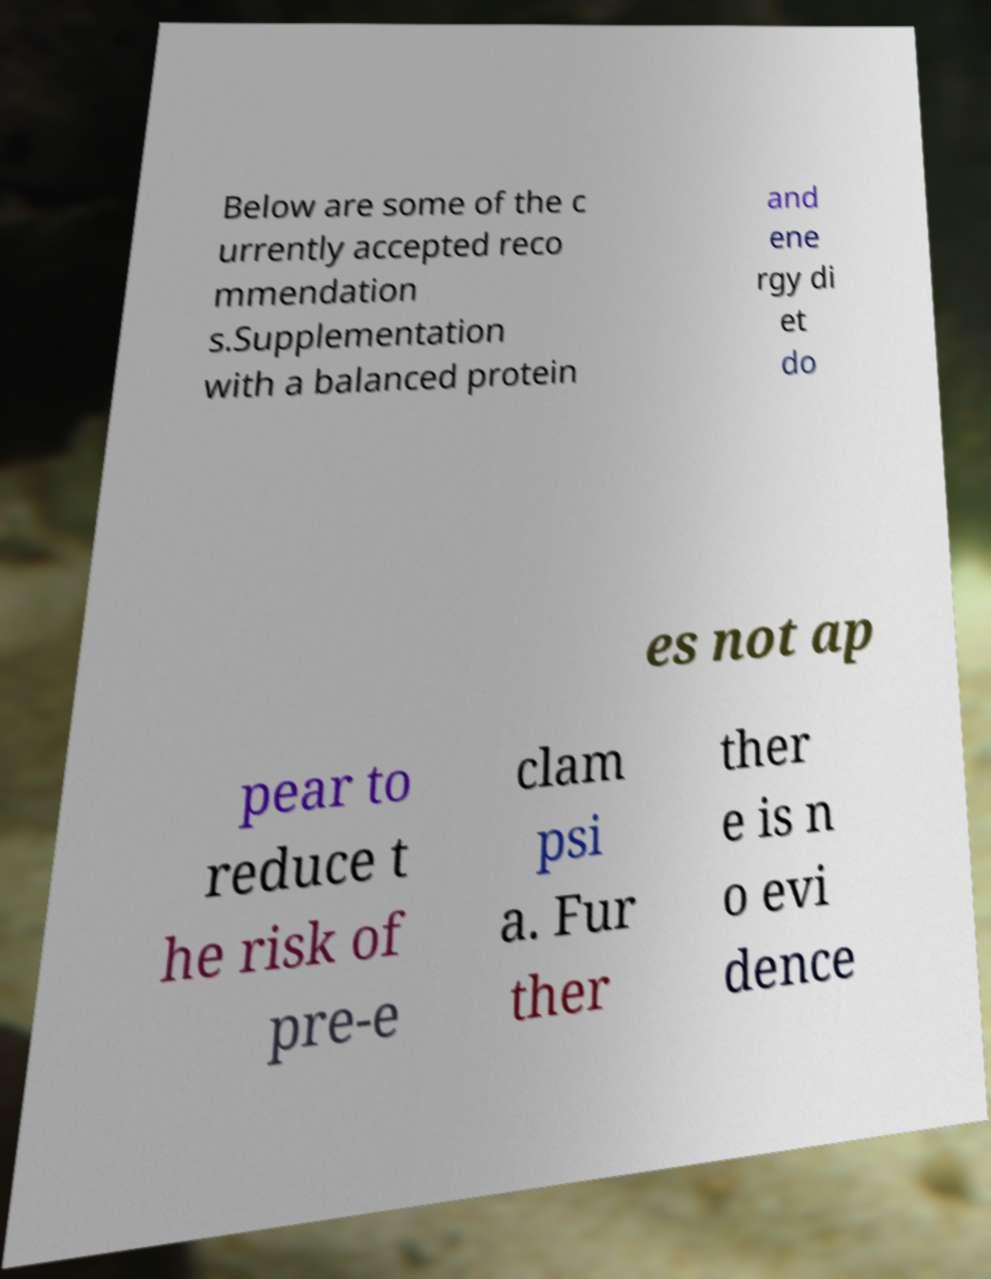Could you extract and type out the text from this image? Below are some of the c urrently accepted reco mmendation s.Supplementation with a balanced protein and ene rgy di et do es not ap pear to reduce t he risk of pre-e clam psi a. Fur ther ther e is n o evi dence 